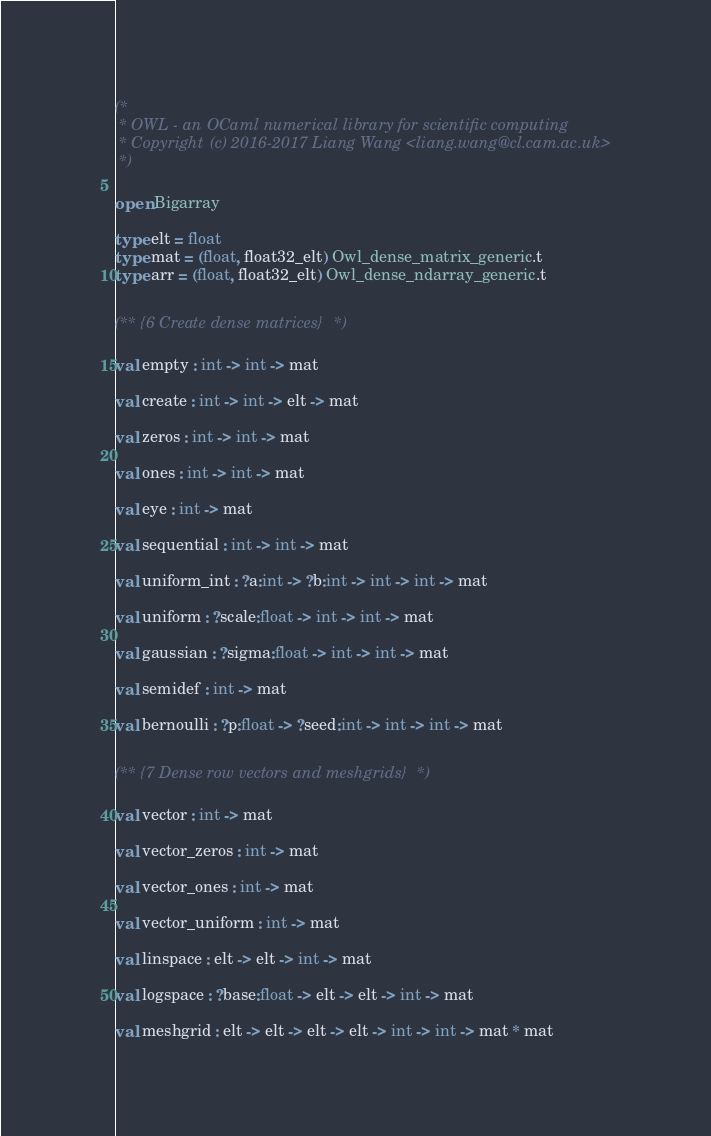<code> <loc_0><loc_0><loc_500><loc_500><_OCaml_>(*
 * OWL - an OCaml numerical library for scientific computing
 * Copyright (c) 2016-2017 Liang Wang <liang.wang@cl.cam.ac.uk>
 *)

open Bigarray

type elt = float
type mat = (float, float32_elt) Owl_dense_matrix_generic.t
type arr = (float, float32_elt) Owl_dense_ndarray_generic.t


(** {6 Create dense matrices} *)

val empty : int -> int -> mat

val create : int -> int -> elt -> mat

val zeros : int -> int -> mat

val ones : int -> int -> mat

val eye : int -> mat

val sequential : int -> int -> mat

val uniform_int : ?a:int -> ?b:int -> int -> int -> mat

val uniform : ?scale:float -> int -> int -> mat

val gaussian : ?sigma:float -> int -> int -> mat

val semidef : int -> mat

val bernoulli : ?p:float -> ?seed:int -> int -> int -> mat


(** {7 Dense row vectors and meshgrids} *)

val vector : int -> mat

val vector_zeros : int -> mat

val vector_ones : int -> mat

val vector_uniform : int -> mat

val linspace : elt -> elt -> int -> mat

val logspace : ?base:float -> elt -> elt -> int -> mat

val meshgrid : elt -> elt -> elt -> elt -> int -> int -> mat * mat
</code> 